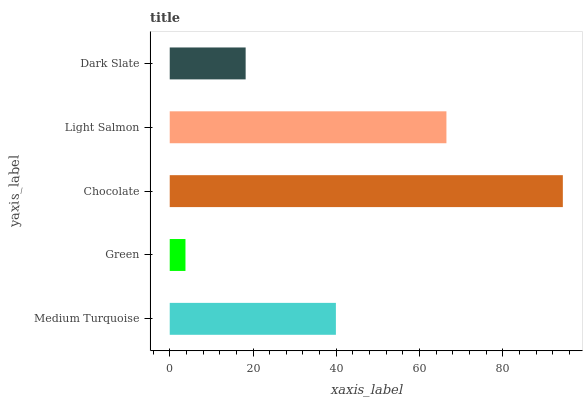Is Green the minimum?
Answer yes or no. Yes. Is Chocolate the maximum?
Answer yes or no. Yes. Is Chocolate the minimum?
Answer yes or no. No. Is Green the maximum?
Answer yes or no. No. Is Chocolate greater than Green?
Answer yes or no. Yes. Is Green less than Chocolate?
Answer yes or no. Yes. Is Green greater than Chocolate?
Answer yes or no. No. Is Chocolate less than Green?
Answer yes or no. No. Is Medium Turquoise the high median?
Answer yes or no. Yes. Is Medium Turquoise the low median?
Answer yes or no. Yes. Is Chocolate the high median?
Answer yes or no. No. Is Green the low median?
Answer yes or no. No. 